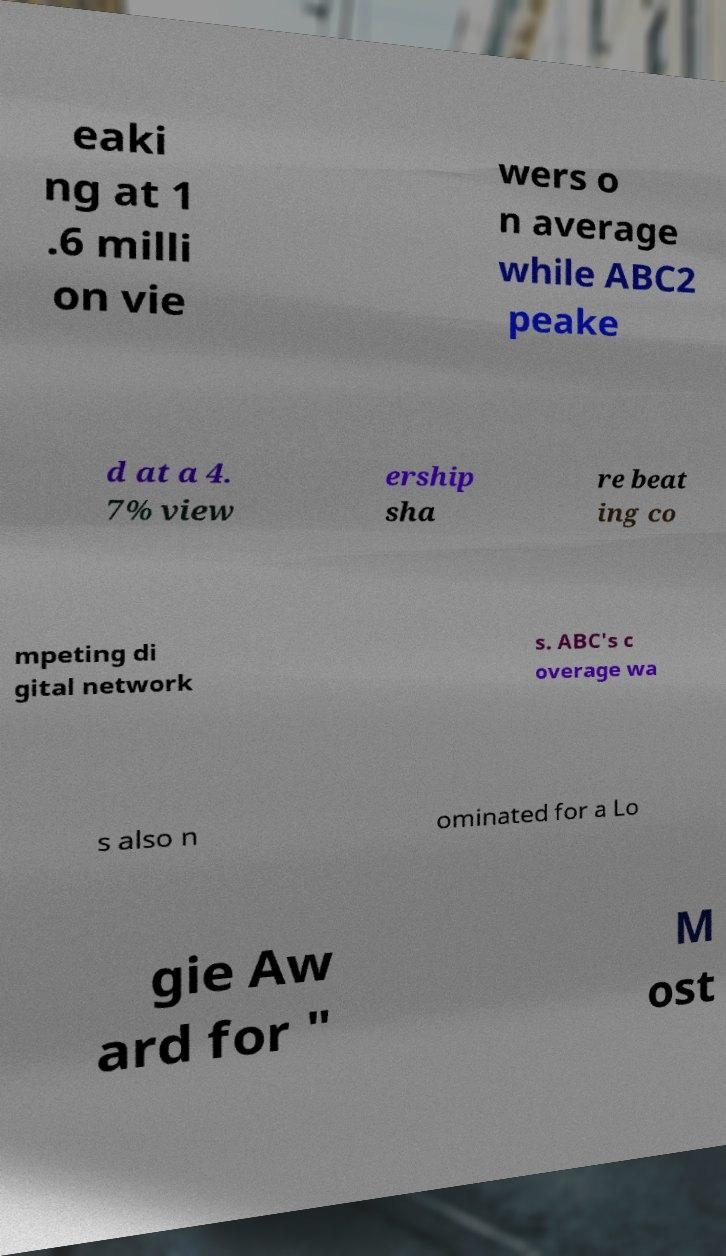I need the written content from this picture converted into text. Can you do that? eaki ng at 1 .6 milli on vie wers o n average while ABC2 peake d at a 4. 7% view ership sha re beat ing co mpeting di gital network s. ABC's c overage wa s also n ominated for a Lo gie Aw ard for " M ost 